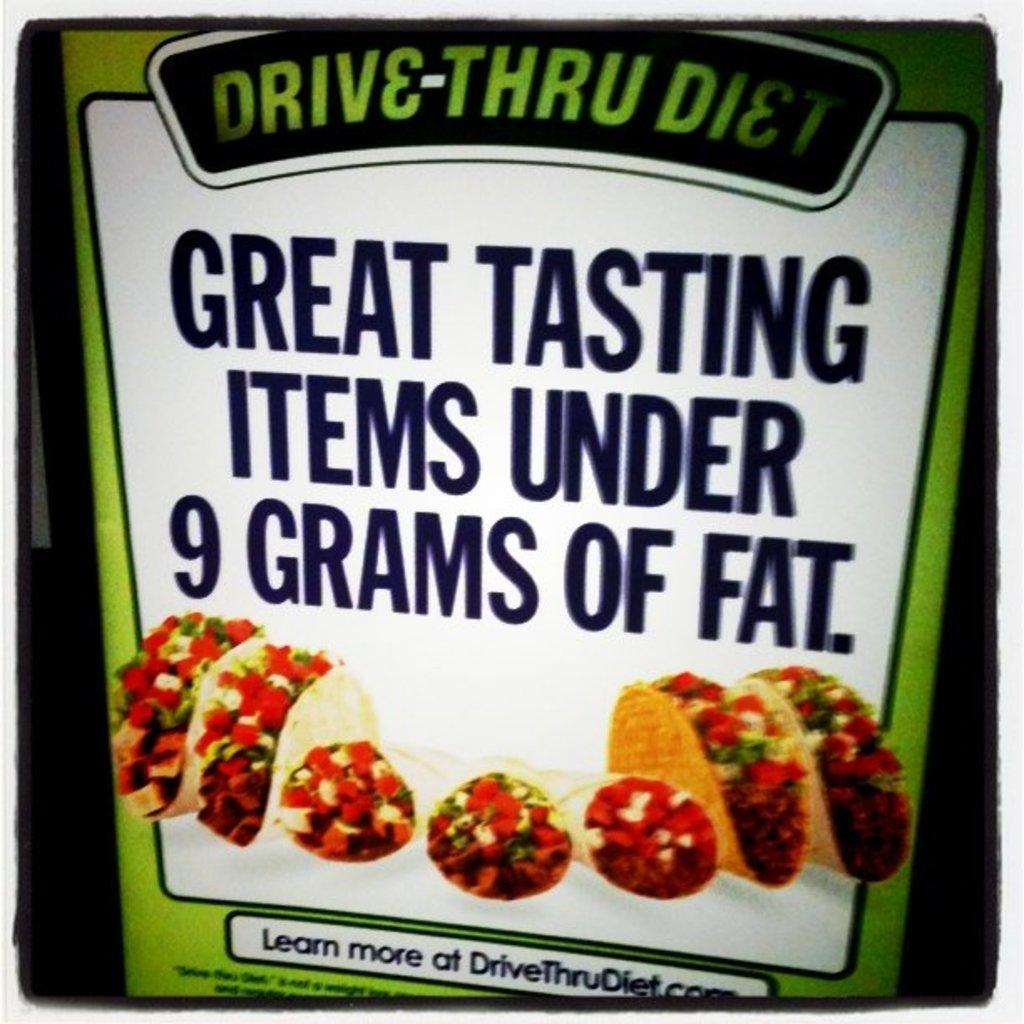What type of product is shown in the image? There is a food item product in the image. What is the name of the product? The product has a name: "drive through diet". What can be seen on the product besides its name? There are images of food items on the product. What type of boot is shown in the image? There is no boot present in the image; it features a food item product called "drive through diet". 